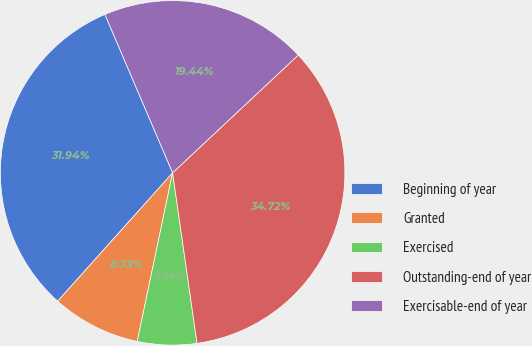Convert chart to OTSL. <chart><loc_0><loc_0><loc_500><loc_500><pie_chart><fcel>Beginning of year<fcel>Granted<fcel>Exercised<fcel>Outstanding-end of year<fcel>Exercisable-end of year<nl><fcel>31.94%<fcel>8.33%<fcel>5.56%<fcel>34.72%<fcel>19.44%<nl></chart> 